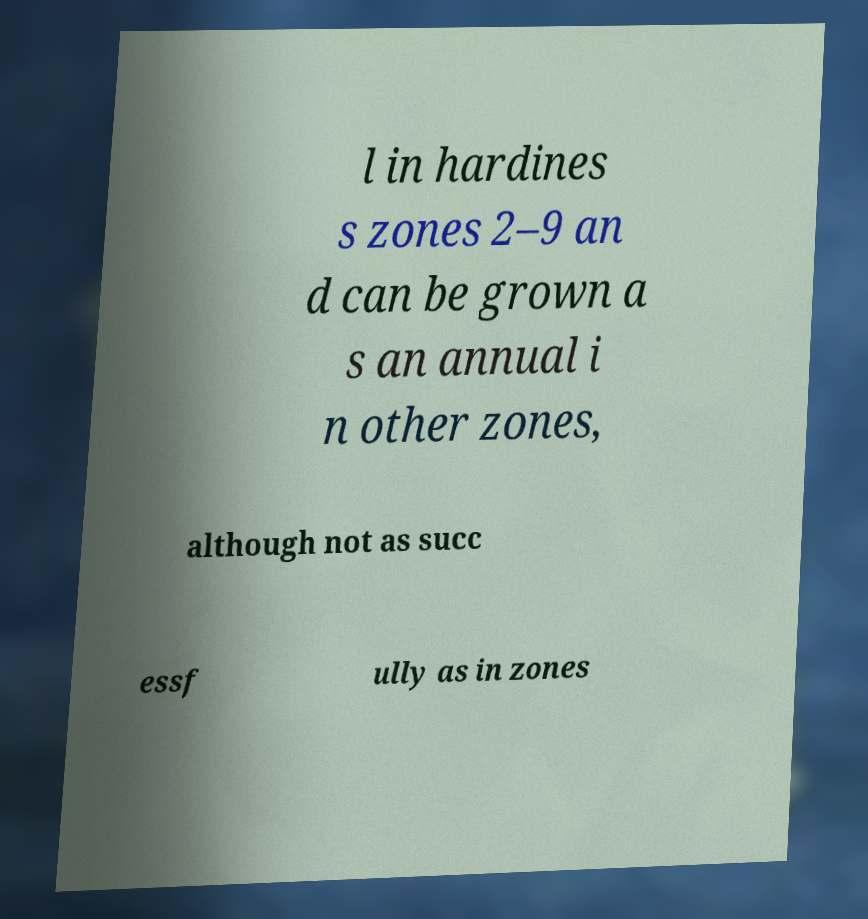There's text embedded in this image that I need extracted. Can you transcribe it verbatim? l in hardines s zones 2–9 an d can be grown a s an annual i n other zones, although not as succ essf ully as in zones 